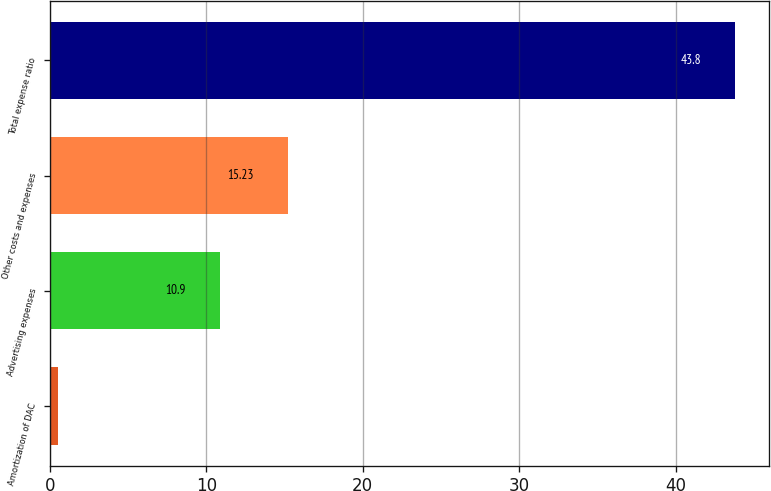Convert chart to OTSL. <chart><loc_0><loc_0><loc_500><loc_500><bar_chart><fcel>Amortization of DAC<fcel>Advertising expenses<fcel>Other costs and expenses<fcel>Total expense ratio<nl><fcel>0.5<fcel>10.9<fcel>15.23<fcel>43.8<nl></chart> 